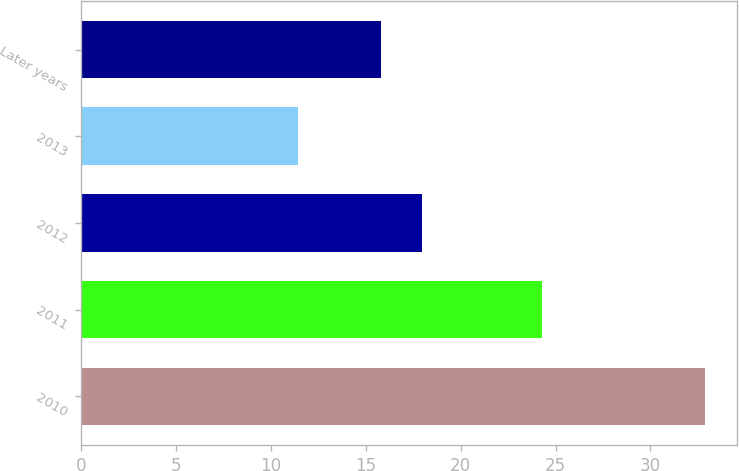Convert chart. <chart><loc_0><loc_0><loc_500><loc_500><bar_chart><fcel>2010<fcel>2011<fcel>2012<fcel>2013<fcel>Later years<nl><fcel>32.9<fcel>24.3<fcel>17.95<fcel>11.4<fcel>15.8<nl></chart> 